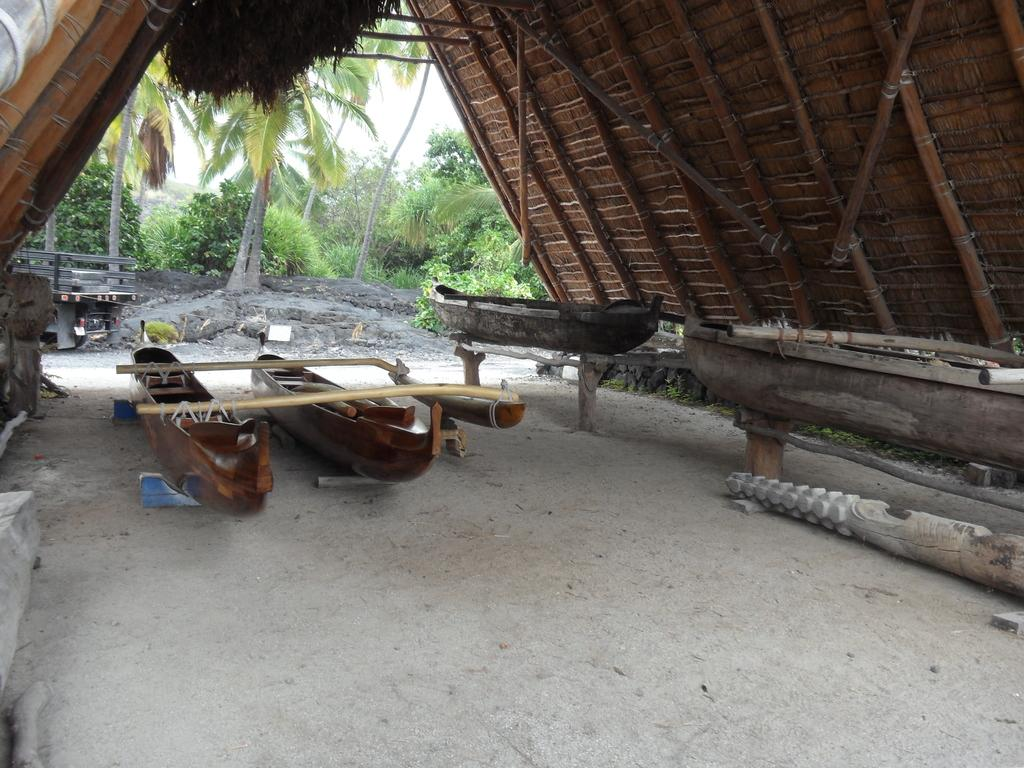What structure is located on the ground in the image? There is a shed on the ground in the image. What type of vehicles can be seen in the image? There are boats in the image. What type of natural vegetation is present in the image? There are trees in the image. What else can be seen in the image besides the shed, boats, and trees? There are some objects in the image. What is visible in the background of the image? The sky is visible in the background of the image. What type of science experiment is being conducted in the image? There is no science experiment present in the image; it features a shed, boats, trees, objects, and a visible sky. What type of music can be heard coming from the shed in the image? There is no indication of music or any sound in the image, as it only shows a shed, boats, trees, objects, and a visible sky. 